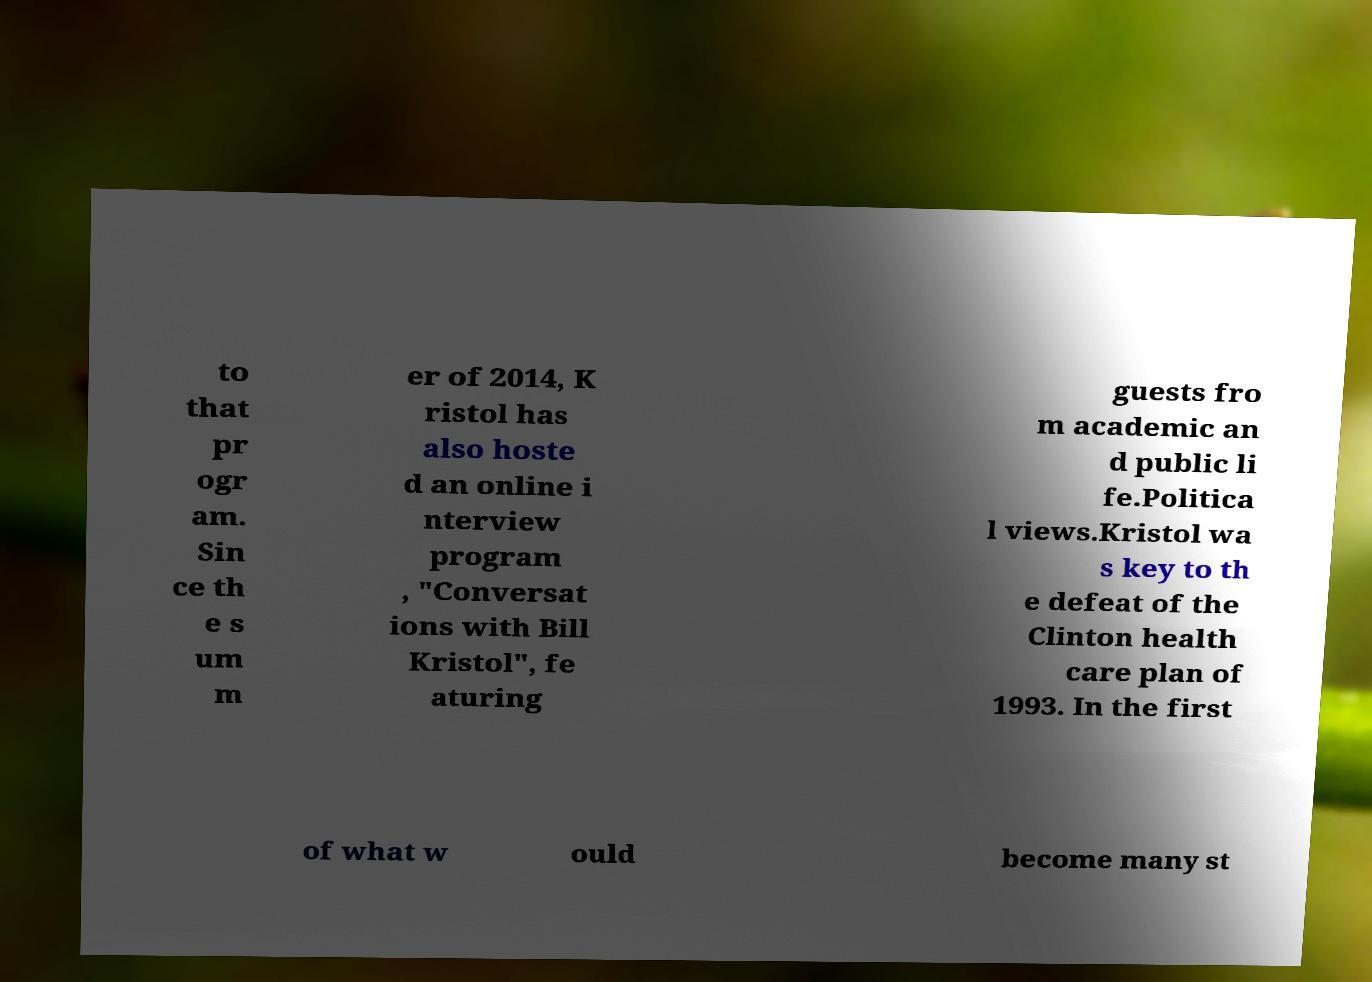Could you extract and type out the text from this image? to that pr ogr am. Sin ce th e s um m er of 2014, K ristol has also hoste d an online i nterview program , "Conversat ions with Bill Kristol", fe aturing guests fro m academic an d public li fe.Politica l views.Kristol wa s key to th e defeat of the Clinton health care plan of 1993. In the first of what w ould become many st 